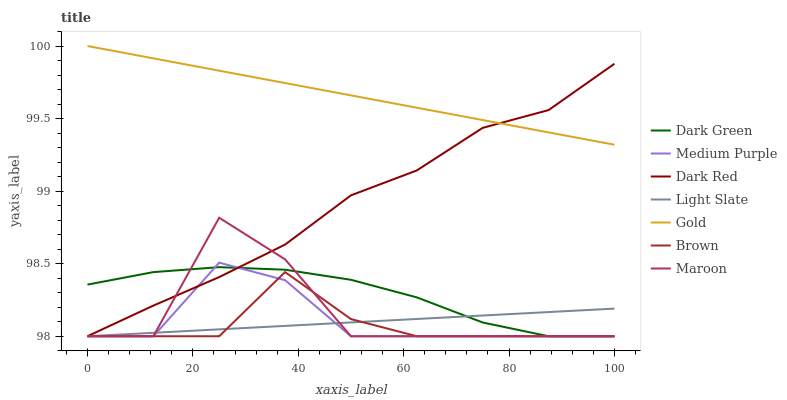Does Brown have the minimum area under the curve?
Answer yes or no. Yes. Does Gold have the maximum area under the curve?
Answer yes or no. Yes. Does Light Slate have the minimum area under the curve?
Answer yes or no. No. Does Light Slate have the maximum area under the curve?
Answer yes or no. No. Is Light Slate the smoothest?
Answer yes or no. Yes. Is Maroon the roughest?
Answer yes or no. Yes. Is Gold the smoothest?
Answer yes or no. No. Is Gold the roughest?
Answer yes or no. No. Does Brown have the lowest value?
Answer yes or no. Yes. Does Gold have the lowest value?
Answer yes or no. No. Does Gold have the highest value?
Answer yes or no. Yes. Does Light Slate have the highest value?
Answer yes or no. No. Is Brown less than Gold?
Answer yes or no. Yes. Is Gold greater than Brown?
Answer yes or no. Yes. Does Medium Purple intersect Maroon?
Answer yes or no. Yes. Is Medium Purple less than Maroon?
Answer yes or no. No. Is Medium Purple greater than Maroon?
Answer yes or no. No. Does Brown intersect Gold?
Answer yes or no. No. 